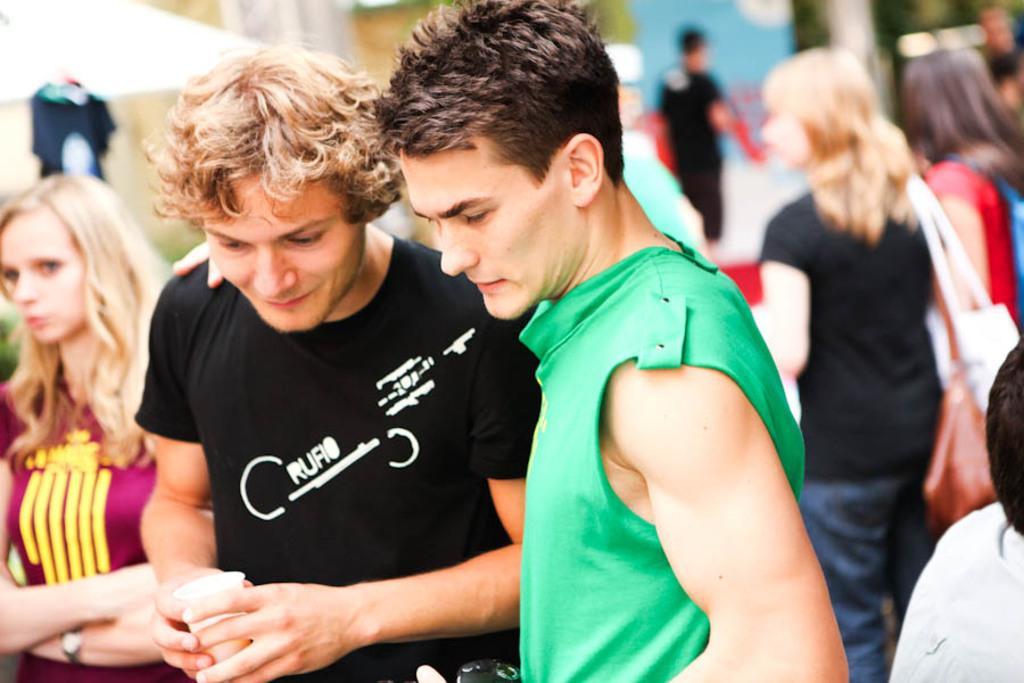How would you summarize this image in a sentence or two? This picture seems to be clicked outside and we can see the group of persons, sling bags and a person wearing t-shirt holding a glass and standing. In the background we can see the group of persons and many other objects. 